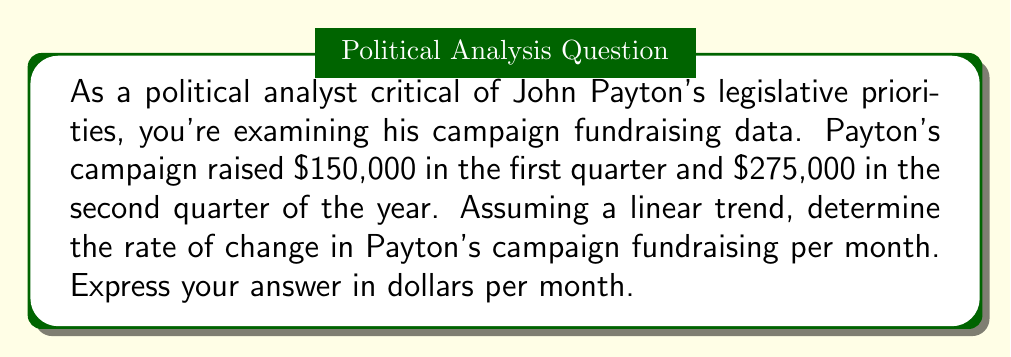Can you answer this question? To solve this problem, we need to follow these steps:

1) First, let's identify the key information:
   - First quarter fundraising: $150,000
   - Second quarter fundraising: $275,000
   - We're assuming a linear trend
   - We need to find the rate of change per month

2) Calculate the total change in fundraising:
   $\text{Change} = \text{Q2 fundraising} - \text{Q1 fundraising}$
   $\text{Change} = \$275,000 - \$150,000 = \$125,000$

3) Determine the time period:
   - Each quarter is 3 months
   - From the middle of Q1 to the middle of Q2 is 3 months

4) Calculate the rate of change:
   $$\text{Rate of change} = \frac{\text{Change in fundraising}}{\text{Change in time}}$$
   
   $$\text{Rate of change} = \frac{\$125,000}{3 \text{ months}}$$
   
   $$\text{Rate of change} = \$41,666.67 \text{ per month}$$

This rate of change indicates that, on average, Payton's campaign is increasing its fundraising by about $41,666.67 each month, assuming the trend continues linearly.
Answer: $41,666.67 per month 